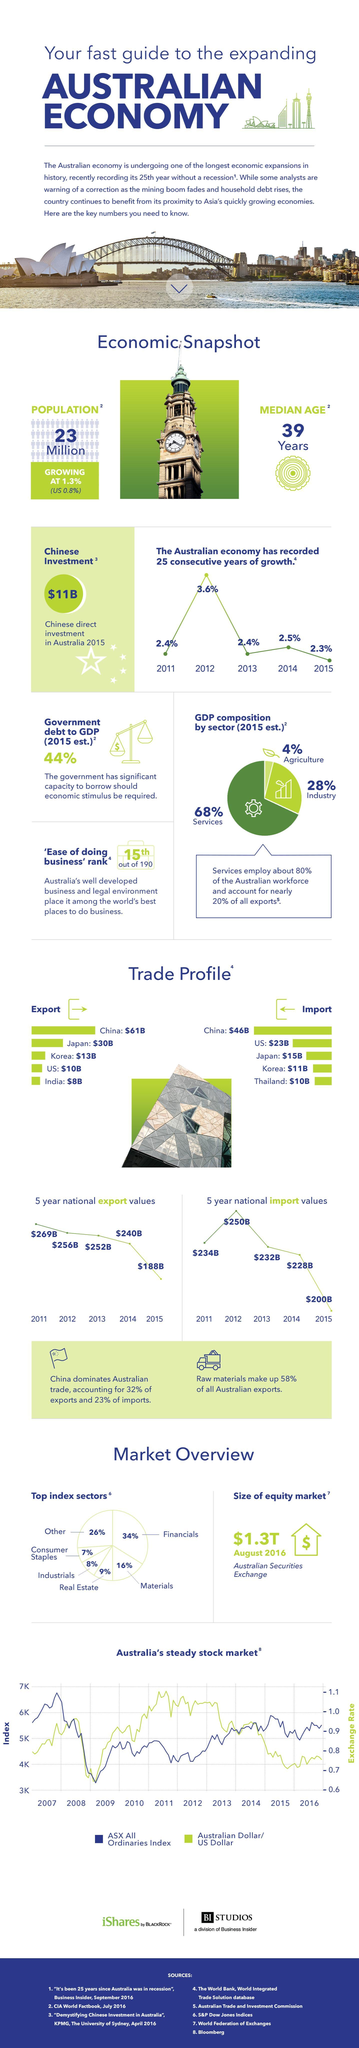What is the national export value in the year 2013 in Australia?
Answer the question with a short phrase. $252B What is the estimated percentage of GDP composition by services in Australia in 2015? 68% What is the growth rate of Australian economy in the year 2014? 2.5% What is the value of Chinese direct investment in Australia in the year 2015? $11B What is the national import value in the year 2015 in Australia? $200B What is the growth rate of Australian economy in the year 2012? 3.6% What is the national export value in the year 2014 in Australia? $240B What is the estimated percentage of GDP composition by agricultural sector in Australia in 2015? 4% 